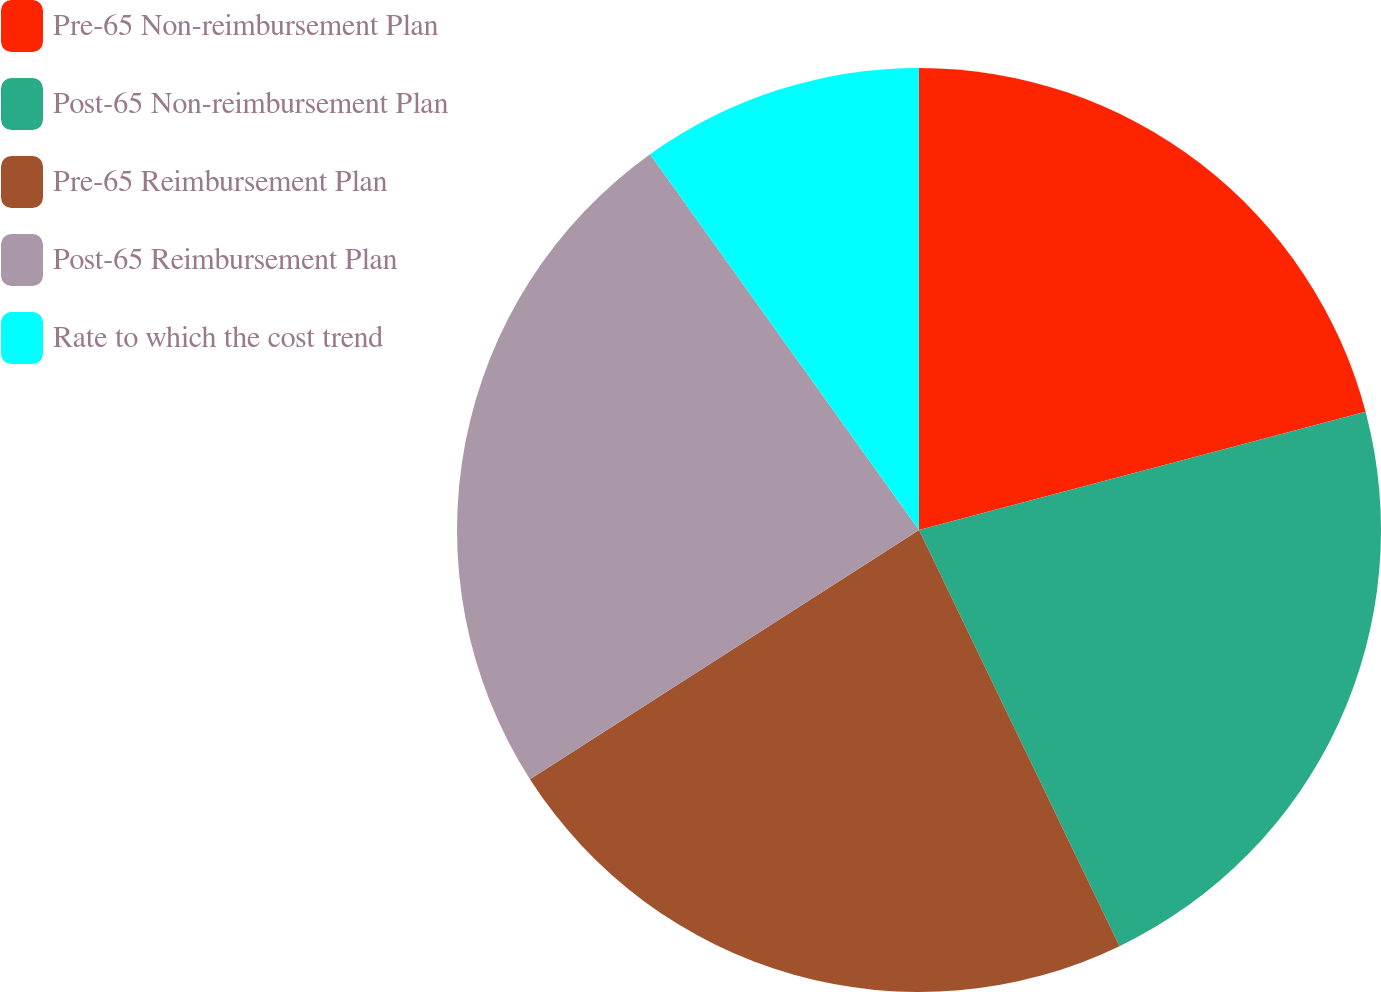<chart> <loc_0><loc_0><loc_500><loc_500><pie_chart><fcel>Pre-65 Non-reimbursement Plan<fcel>Post-65 Non-reimbursement Plan<fcel>Pre-65 Reimbursement Plan<fcel>Post-65 Reimbursement Plan<fcel>Rate to which the cost trend<nl><fcel>20.88%<fcel>21.98%<fcel>23.08%<fcel>24.18%<fcel>9.89%<nl></chart> 